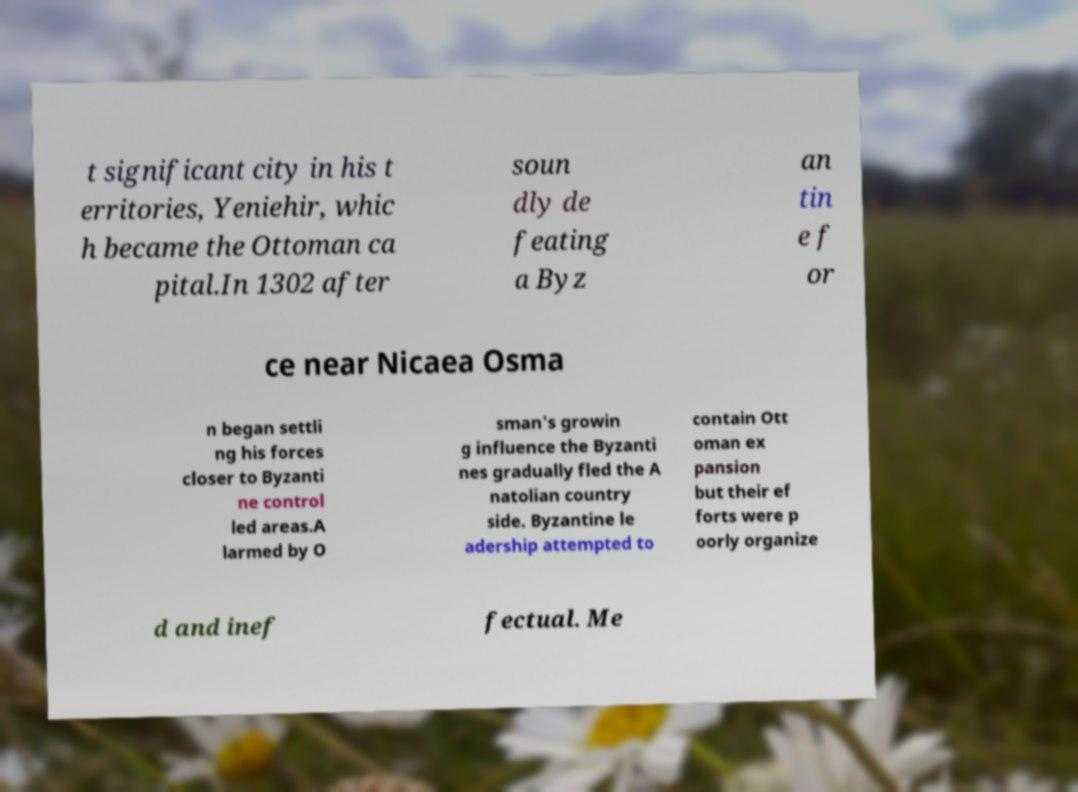What role did Yeniehir play in Ottoman history according to the text? According to the text, Yeniehir was significant as it became the capital of the Ottoman territories under Osman I. Its establishment as the capital marked a pivotal point in solidifying Ottoman rule and served as a base for further military and administrative operations during the early years of the empire. 